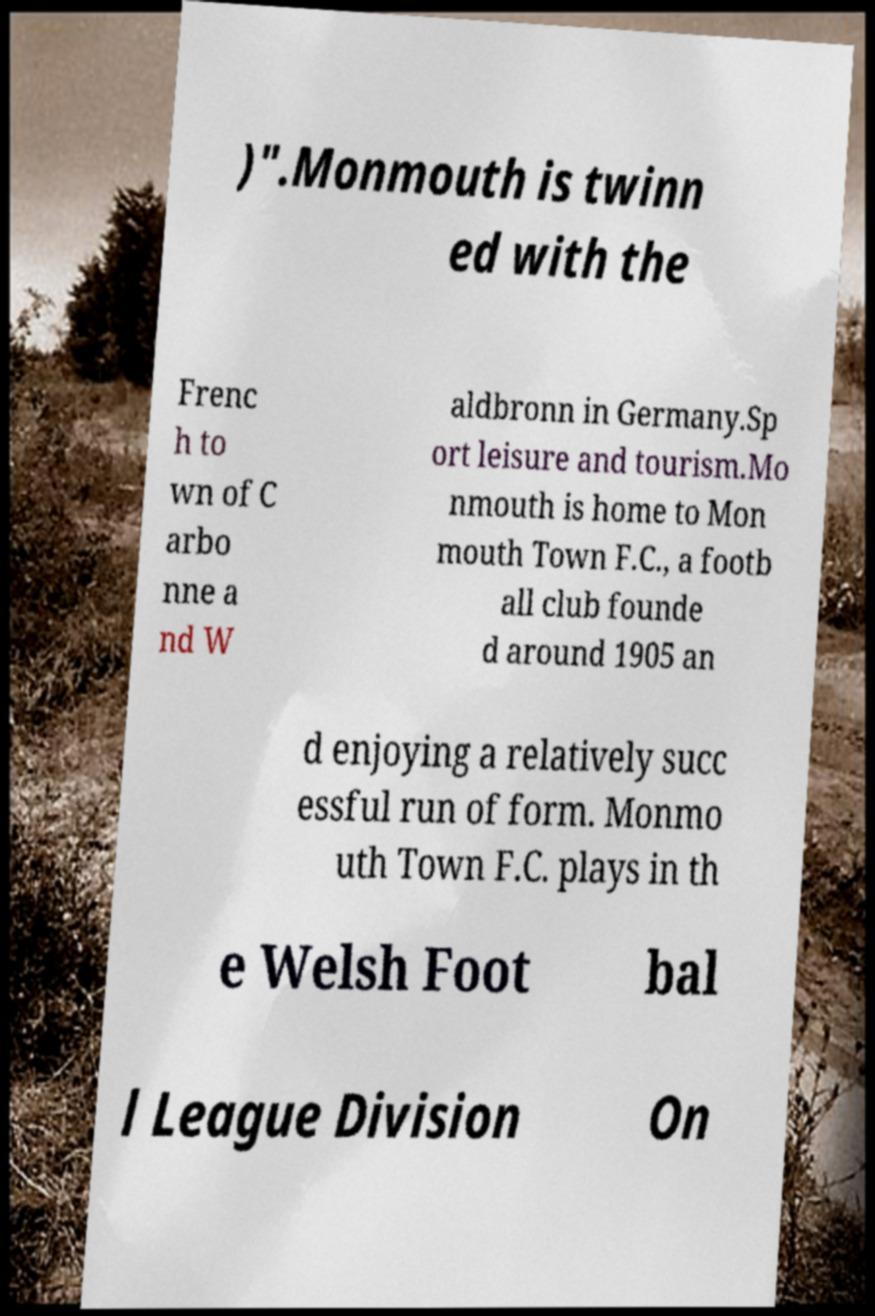Could you extract and type out the text from this image? )".Monmouth is twinn ed with the Frenc h to wn of C arbo nne a nd W aldbronn in Germany.Sp ort leisure and tourism.Mo nmouth is home to Mon mouth Town F.C., a footb all club founde d around 1905 an d enjoying a relatively succ essful run of form. Monmo uth Town F.C. plays in th e Welsh Foot bal l League Division On 